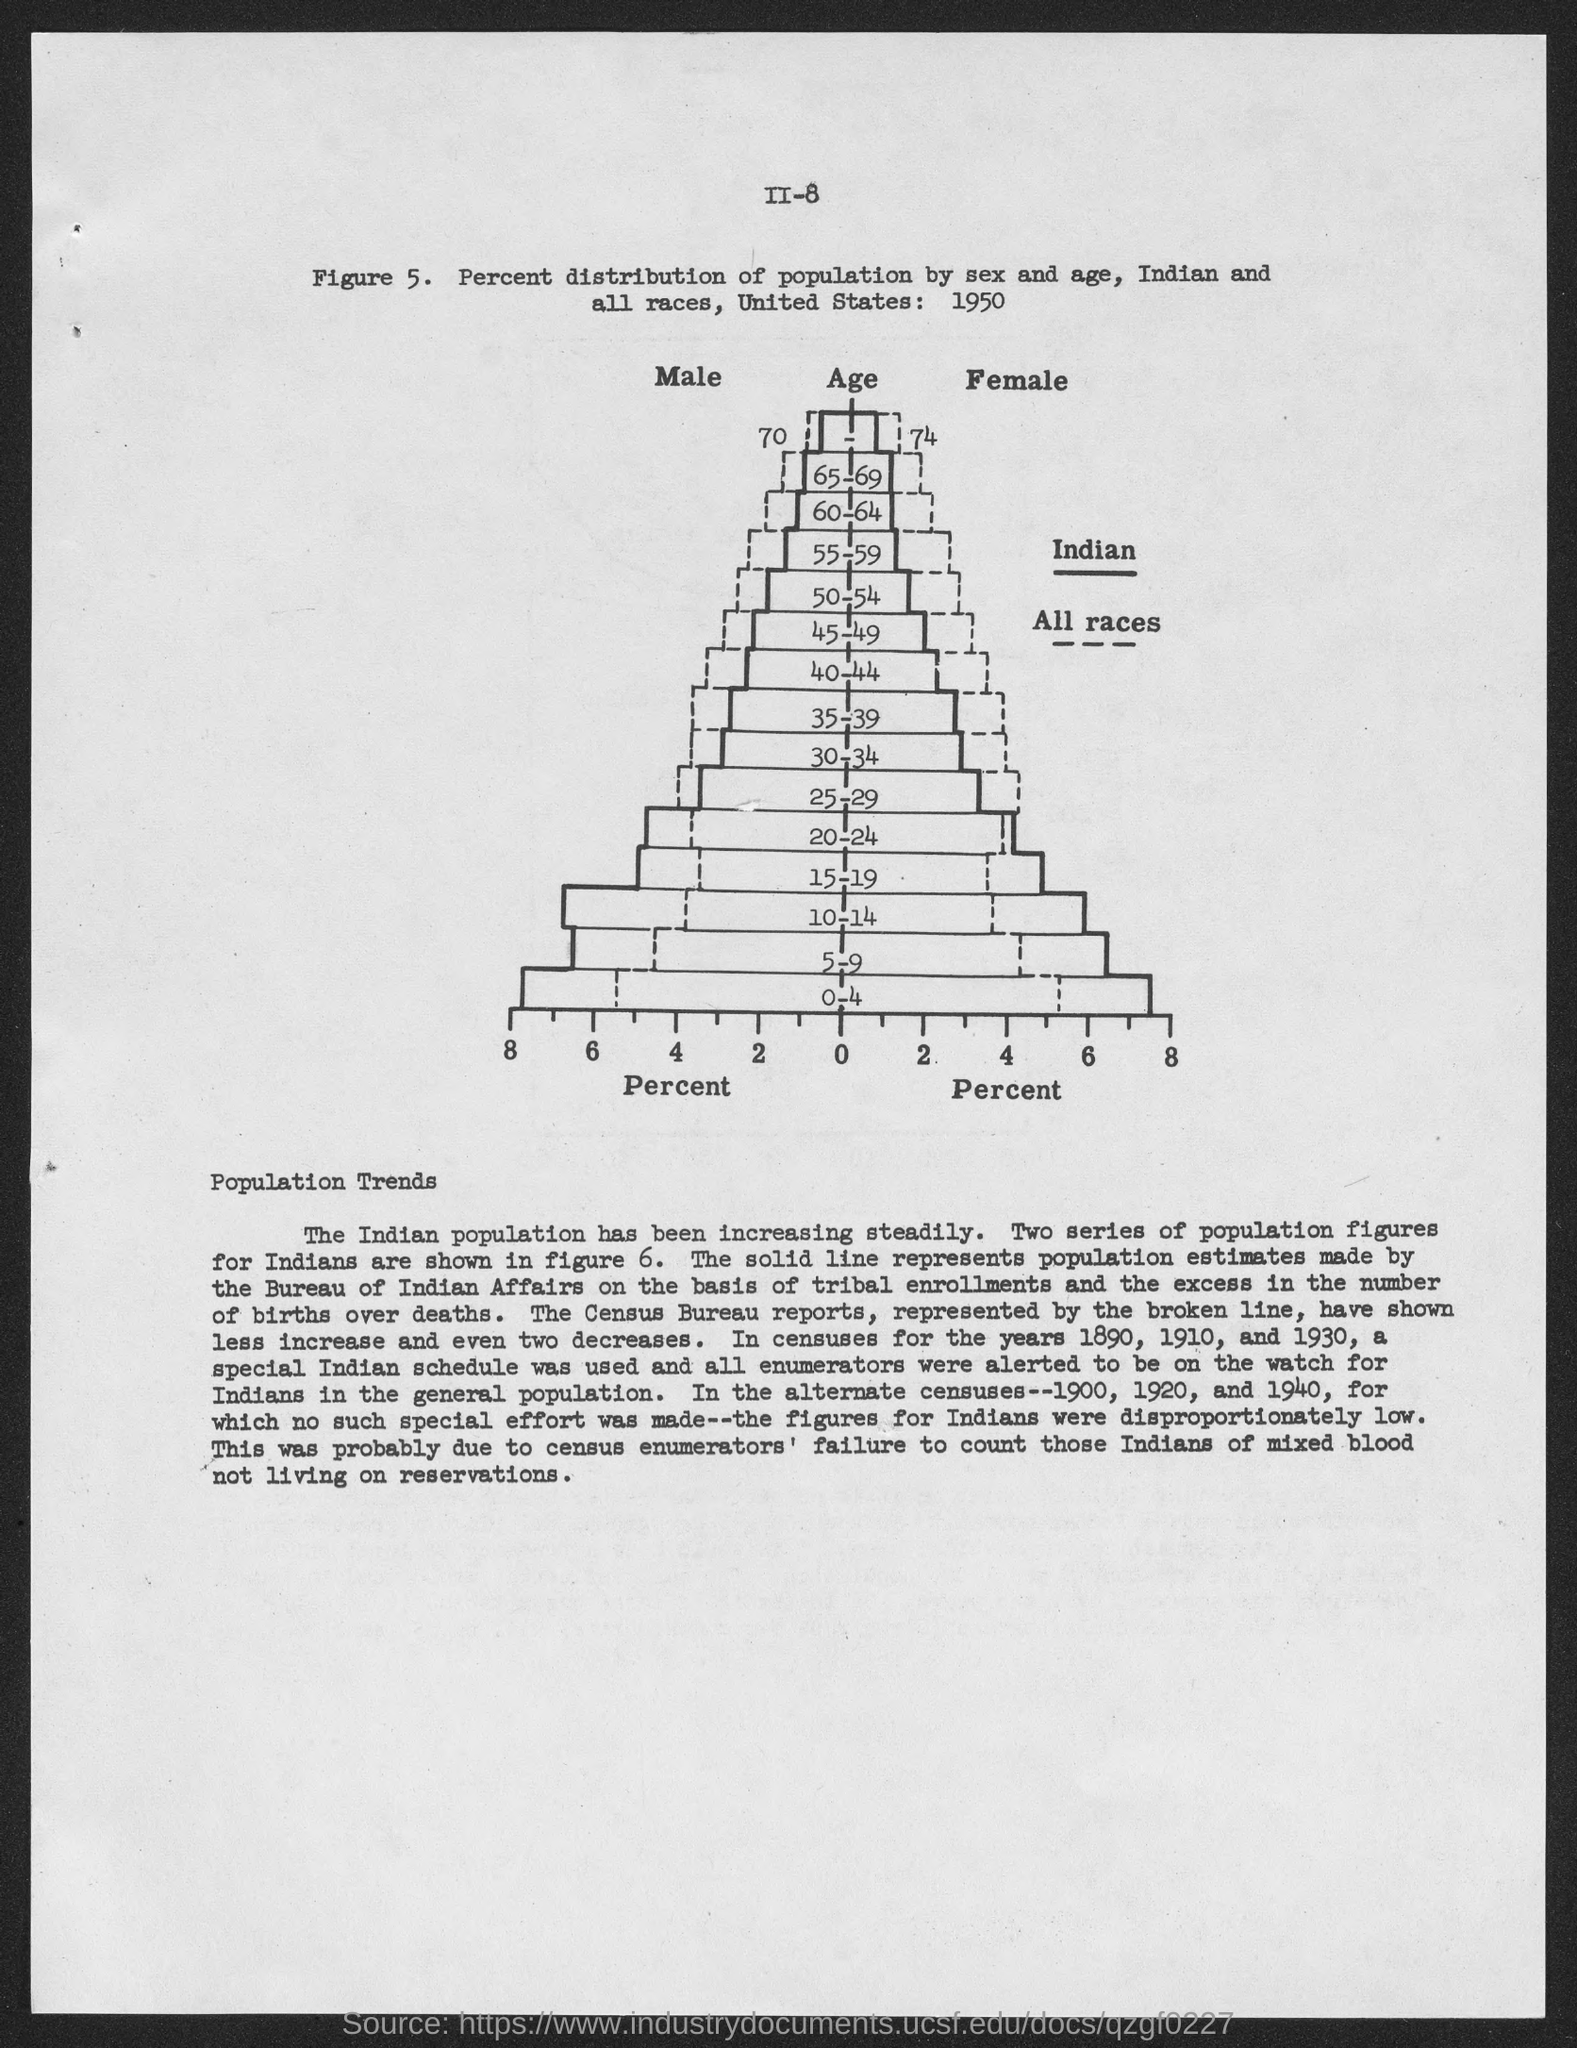What is on the X-axis of the graph?
Make the answer very short. Percent. Percent distribution of population by sex and age,Indian and all races is done by which country?
Give a very brief answer. United States. United States has done the percentage distribution of population study in which year?
Offer a very short reply. 1950. What is on the Y-axis of the graph?
Your answer should be very brief. Age. How many series of population figures for Indians are shown in figure 6?
Make the answer very short. TWO SERIES. Percent distribution of population by sex and age has been done among whom?
Offer a very short reply. INDIAN AND ALL RACES. Which is the lowest age group on which percent distribution of population study has been done?
Offer a terse response. 0-4. What sub heading is given to the explanation of Figure 5?
Your answer should be very brief. Population Trends. 